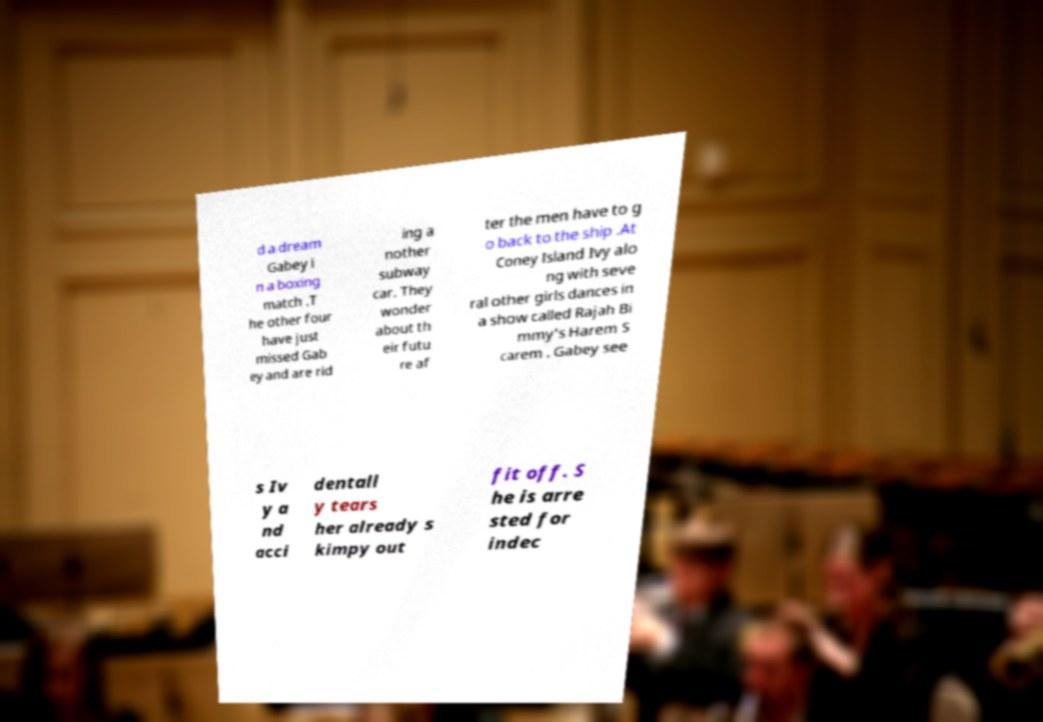Please identify and transcribe the text found in this image. d a dream Gabey i n a boxing match .T he other four have just missed Gab ey and are rid ing a nother subway car. They wonder about th eir futu re af ter the men have to g o back to the ship .At Coney Island Ivy alo ng with seve ral other girls dances in a show called Rajah Bi mmy's Harem S carem . Gabey see s Iv y a nd acci dentall y tears her already s kimpy out fit off. S he is arre sted for indec 